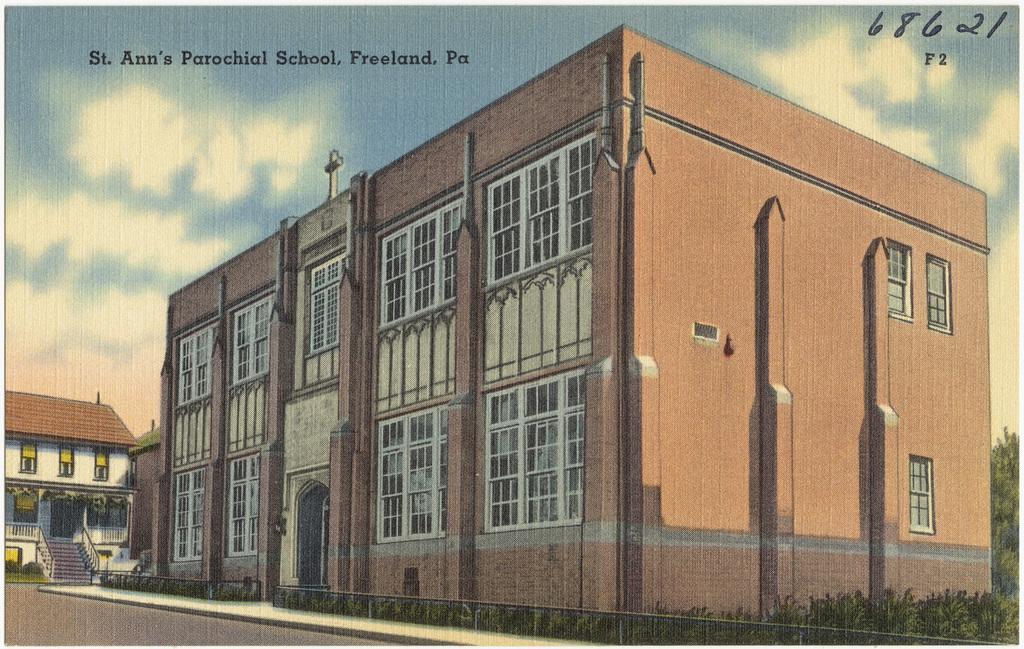In one or two sentences, can you explain what this image depicts? In the image we can see the poster in the poster we can see buildings, plants, stairs, road and the sky. 